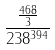Convert formula to latex. <formula><loc_0><loc_0><loc_500><loc_500>\frac { \frac { 4 6 8 } { 3 } } { 2 3 8 ^ { 3 9 4 } }</formula> 